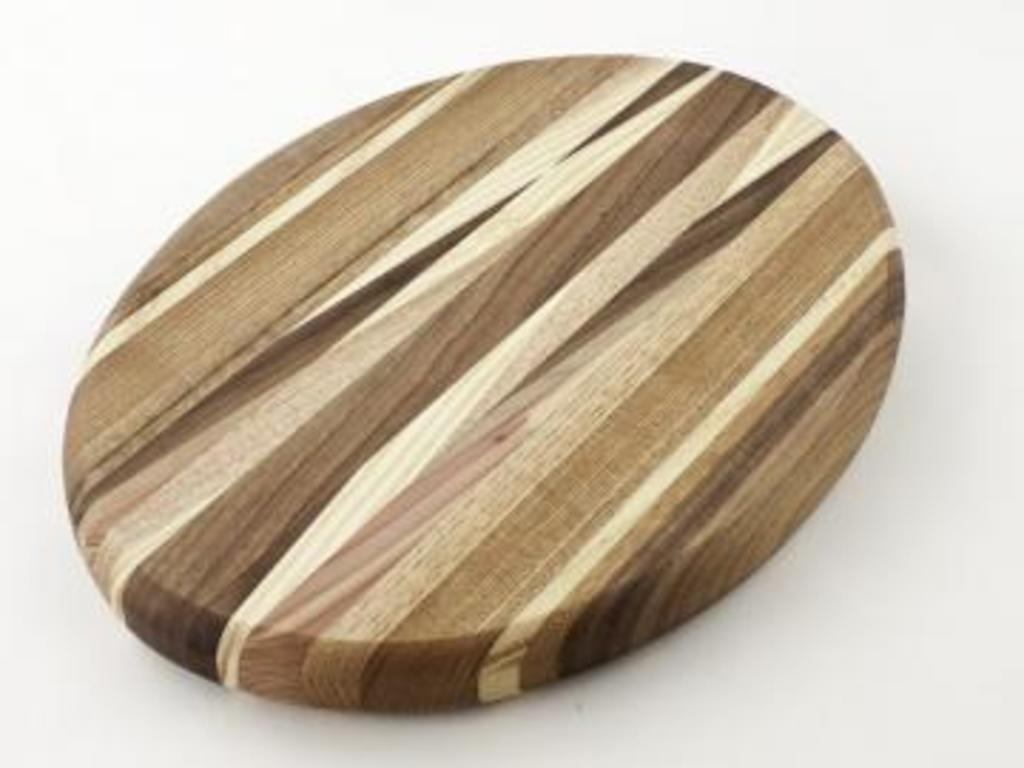What material is the object in the image made of? The object is a wooden plank. Can you describe the shape of the wooden plank? The wooden plank is in the shape of an oval. What type of button can be seen on the wooden plank in the image? There is no button present on the wooden plank in the image. 